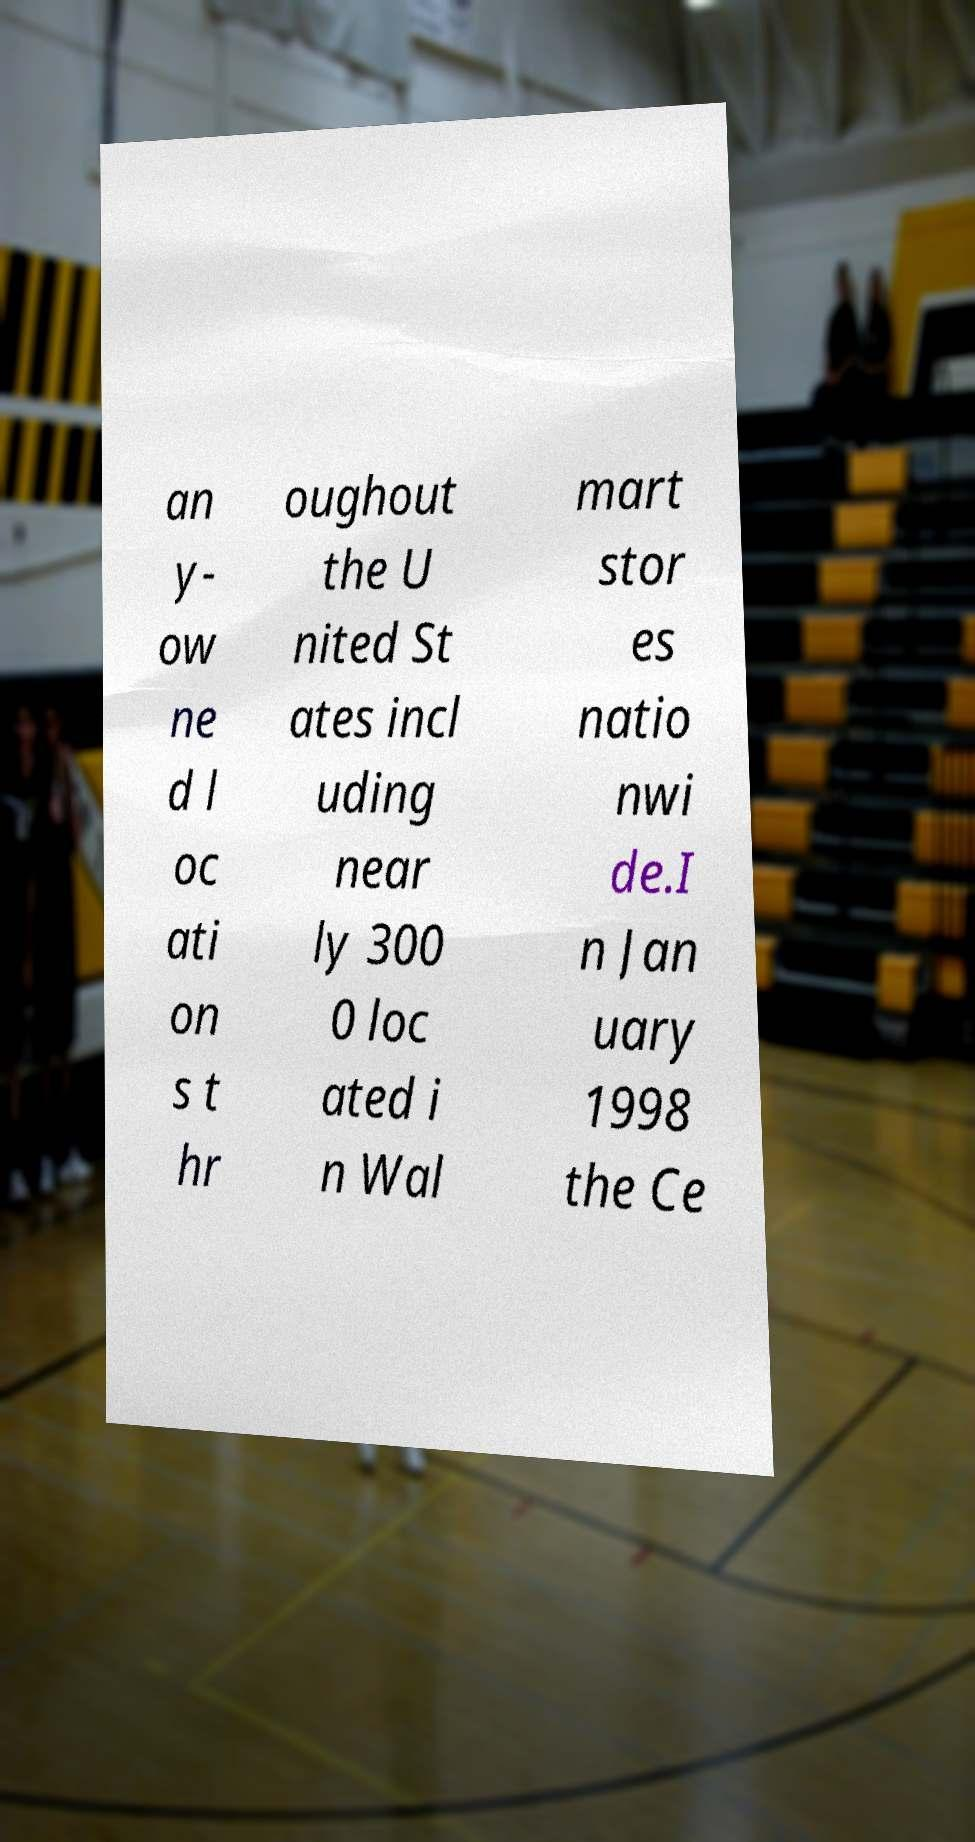There's text embedded in this image that I need extracted. Can you transcribe it verbatim? an y- ow ne d l oc ati on s t hr oughout the U nited St ates incl uding near ly 300 0 loc ated i n Wal mart stor es natio nwi de.I n Jan uary 1998 the Ce 